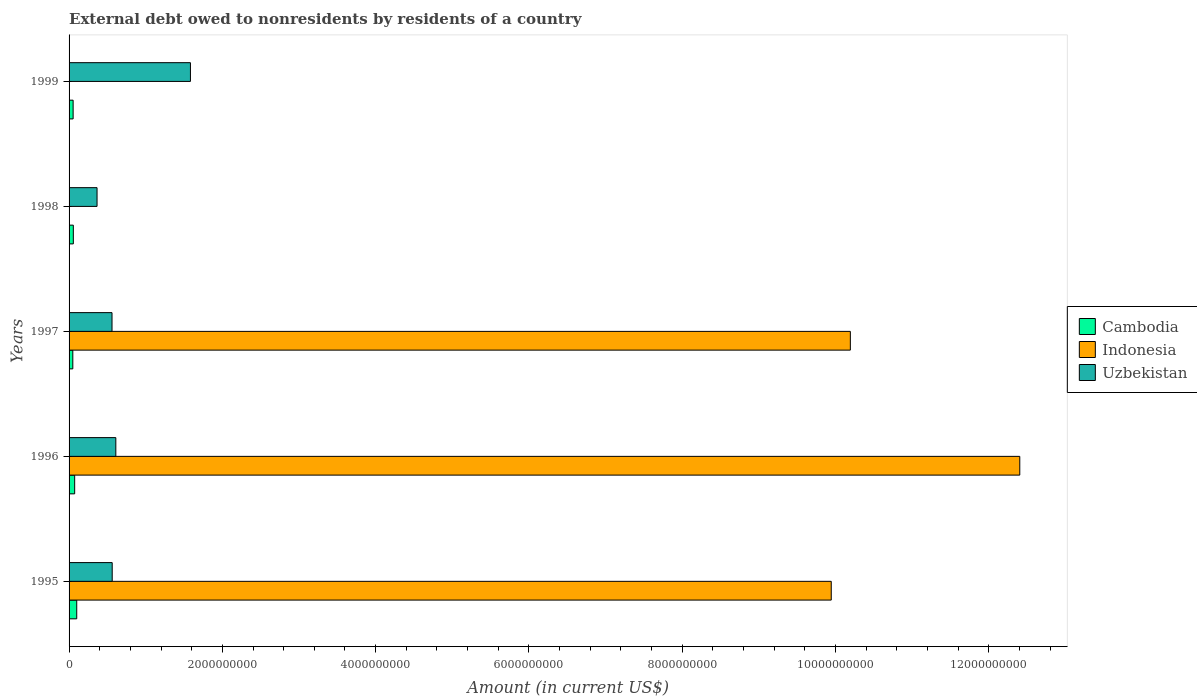How many groups of bars are there?
Your response must be concise. 5. Are the number of bars on each tick of the Y-axis equal?
Offer a terse response. No. What is the label of the 1st group of bars from the top?
Provide a succinct answer. 1999. Across all years, what is the maximum external debt owed by residents in Indonesia?
Your answer should be very brief. 1.24e+1. Across all years, what is the minimum external debt owed by residents in Indonesia?
Your answer should be compact. 0. What is the total external debt owed by residents in Indonesia in the graph?
Ensure brevity in your answer.  3.25e+1. What is the difference between the external debt owed by residents in Uzbekistan in 1996 and that in 1997?
Your answer should be very brief. 4.98e+07. What is the difference between the external debt owed by residents in Indonesia in 1996 and the external debt owed by residents in Uzbekistan in 1995?
Your answer should be very brief. 1.18e+1. What is the average external debt owed by residents in Uzbekistan per year?
Ensure brevity in your answer.  7.36e+08. In the year 1997, what is the difference between the external debt owed by residents in Indonesia and external debt owed by residents in Cambodia?
Provide a succinct answer. 1.01e+1. In how many years, is the external debt owed by residents in Indonesia greater than 11200000000 US$?
Make the answer very short. 1. What is the ratio of the external debt owed by residents in Uzbekistan in 1995 to that in 1996?
Your answer should be compact. 0.92. What is the difference between the highest and the second highest external debt owed by residents in Cambodia?
Your answer should be compact. 2.69e+07. What is the difference between the highest and the lowest external debt owed by residents in Uzbekistan?
Your answer should be compact. 1.22e+09. In how many years, is the external debt owed by residents in Cambodia greater than the average external debt owed by residents in Cambodia taken over all years?
Give a very brief answer. 2. How many bars are there?
Give a very brief answer. 13. Are all the bars in the graph horizontal?
Give a very brief answer. Yes. How are the legend labels stacked?
Make the answer very short. Vertical. What is the title of the graph?
Ensure brevity in your answer.  External debt owed to nonresidents by residents of a country. Does "Ecuador" appear as one of the legend labels in the graph?
Offer a terse response. No. What is the label or title of the X-axis?
Offer a very short reply. Amount (in current US$). What is the label or title of the Y-axis?
Your response must be concise. Years. What is the Amount (in current US$) of Cambodia in 1995?
Make the answer very short. 1.00e+08. What is the Amount (in current US$) in Indonesia in 1995?
Provide a succinct answer. 9.94e+09. What is the Amount (in current US$) in Uzbekistan in 1995?
Ensure brevity in your answer.  5.63e+08. What is the Amount (in current US$) in Cambodia in 1996?
Your answer should be very brief. 7.31e+07. What is the Amount (in current US$) in Indonesia in 1996?
Ensure brevity in your answer.  1.24e+1. What is the Amount (in current US$) of Uzbekistan in 1996?
Provide a succinct answer. 6.10e+08. What is the Amount (in current US$) in Cambodia in 1997?
Offer a very short reply. 4.88e+07. What is the Amount (in current US$) in Indonesia in 1997?
Keep it short and to the point. 1.02e+1. What is the Amount (in current US$) of Uzbekistan in 1997?
Offer a terse response. 5.60e+08. What is the Amount (in current US$) of Cambodia in 1998?
Your answer should be very brief. 5.55e+07. What is the Amount (in current US$) of Uzbekistan in 1998?
Provide a short and direct response. 3.65e+08. What is the Amount (in current US$) in Cambodia in 1999?
Offer a very short reply. 5.28e+07. What is the Amount (in current US$) of Uzbekistan in 1999?
Your answer should be compact. 1.58e+09. Across all years, what is the maximum Amount (in current US$) of Cambodia?
Provide a short and direct response. 1.00e+08. Across all years, what is the maximum Amount (in current US$) in Indonesia?
Offer a very short reply. 1.24e+1. Across all years, what is the maximum Amount (in current US$) of Uzbekistan?
Give a very brief answer. 1.58e+09. Across all years, what is the minimum Amount (in current US$) in Cambodia?
Provide a short and direct response. 4.88e+07. Across all years, what is the minimum Amount (in current US$) of Indonesia?
Make the answer very short. 0. Across all years, what is the minimum Amount (in current US$) of Uzbekistan?
Keep it short and to the point. 3.65e+08. What is the total Amount (in current US$) of Cambodia in the graph?
Your answer should be compact. 3.30e+08. What is the total Amount (in current US$) of Indonesia in the graph?
Your response must be concise. 3.25e+1. What is the total Amount (in current US$) of Uzbekistan in the graph?
Offer a terse response. 3.68e+09. What is the difference between the Amount (in current US$) of Cambodia in 1995 and that in 1996?
Provide a short and direct response. 2.69e+07. What is the difference between the Amount (in current US$) of Indonesia in 1995 and that in 1996?
Ensure brevity in your answer.  -2.46e+09. What is the difference between the Amount (in current US$) in Uzbekistan in 1995 and that in 1996?
Provide a succinct answer. -4.74e+07. What is the difference between the Amount (in current US$) in Cambodia in 1995 and that in 1997?
Your answer should be compact. 5.12e+07. What is the difference between the Amount (in current US$) in Indonesia in 1995 and that in 1997?
Your answer should be compact. -2.49e+08. What is the difference between the Amount (in current US$) in Uzbekistan in 1995 and that in 1997?
Your response must be concise. 2.35e+06. What is the difference between the Amount (in current US$) of Cambodia in 1995 and that in 1998?
Make the answer very short. 4.45e+07. What is the difference between the Amount (in current US$) in Uzbekistan in 1995 and that in 1998?
Keep it short and to the point. 1.98e+08. What is the difference between the Amount (in current US$) of Cambodia in 1995 and that in 1999?
Ensure brevity in your answer.  4.71e+07. What is the difference between the Amount (in current US$) of Uzbekistan in 1995 and that in 1999?
Ensure brevity in your answer.  -1.02e+09. What is the difference between the Amount (in current US$) in Cambodia in 1996 and that in 1997?
Ensure brevity in your answer.  2.43e+07. What is the difference between the Amount (in current US$) of Indonesia in 1996 and that in 1997?
Offer a terse response. 2.21e+09. What is the difference between the Amount (in current US$) in Uzbekistan in 1996 and that in 1997?
Make the answer very short. 4.98e+07. What is the difference between the Amount (in current US$) in Cambodia in 1996 and that in 1998?
Ensure brevity in your answer.  1.76e+07. What is the difference between the Amount (in current US$) of Uzbekistan in 1996 and that in 1998?
Your answer should be very brief. 2.45e+08. What is the difference between the Amount (in current US$) in Cambodia in 1996 and that in 1999?
Your answer should be compact. 2.03e+07. What is the difference between the Amount (in current US$) in Uzbekistan in 1996 and that in 1999?
Offer a terse response. -9.73e+08. What is the difference between the Amount (in current US$) in Cambodia in 1997 and that in 1998?
Make the answer very short. -6.68e+06. What is the difference between the Amount (in current US$) of Uzbekistan in 1997 and that in 1998?
Provide a short and direct response. 1.95e+08. What is the difference between the Amount (in current US$) of Cambodia in 1997 and that in 1999?
Ensure brevity in your answer.  -4.00e+06. What is the difference between the Amount (in current US$) of Uzbekistan in 1997 and that in 1999?
Keep it short and to the point. -1.02e+09. What is the difference between the Amount (in current US$) in Cambodia in 1998 and that in 1999?
Provide a succinct answer. 2.68e+06. What is the difference between the Amount (in current US$) of Uzbekistan in 1998 and that in 1999?
Ensure brevity in your answer.  -1.22e+09. What is the difference between the Amount (in current US$) of Cambodia in 1995 and the Amount (in current US$) of Indonesia in 1996?
Provide a short and direct response. -1.23e+1. What is the difference between the Amount (in current US$) of Cambodia in 1995 and the Amount (in current US$) of Uzbekistan in 1996?
Your response must be concise. -5.10e+08. What is the difference between the Amount (in current US$) in Indonesia in 1995 and the Amount (in current US$) in Uzbekistan in 1996?
Ensure brevity in your answer.  9.33e+09. What is the difference between the Amount (in current US$) in Cambodia in 1995 and the Amount (in current US$) in Indonesia in 1997?
Your answer should be very brief. -1.01e+1. What is the difference between the Amount (in current US$) in Cambodia in 1995 and the Amount (in current US$) in Uzbekistan in 1997?
Offer a terse response. -4.60e+08. What is the difference between the Amount (in current US$) in Indonesia in 1995 and the Amount (in current US$) in Uzbekistan in 1997?
Offer a terse response. 9.38e+09. What is the difference between the Amount (in current US$) in Cambodia in 1995 and the Amount (in current US$) in Uzbekistan in 1998?
Provide a succinct answer. -2.65e+08. What is the difference between the Amount (in current US$) of Indonesia in 1995 and the Amount (in current US$) of Uzbekistan in 1998?
Make the answer very short. 9.58e+09. What is the difference between the Amount (in current US$) in Cambodia in 1995 and the Amount (in current US$) in Uzbekistan in 1999?
Give a very brief answer. -1.48e+09. What is the difference between the Amount (in current US$) in Indonesia in 1995 and the Amount (in current US$) in Uzbekistan in 1999?
Provide a succinct answer. 8.36e+09. What is the difference between the Amount (in current US$) of Cambodia in 1996 and the Amount (in current US$) of Indonesia in 1997?
Make the answer very short. -1.01e+1. What is the difference between the Amount (in current US$) of Cambodia in 1996 and the Amount (in current US$) of Uzbekistan in 1997?
Ensure brevity in your answer.  -4.87e+08. What is the difference between the Amount (in current US$) in Indonesia in 1996 and the Amount (in current US$) in Uzbekistan in 1997?
Give a very brief answer. 1.18e+1. What is the difference between the Amount (in current US$) in Cambodia in 1996 and the Amount (in current US$) in Uzbekistan in 1998?
Give a very brief answer. -2.92e+08. What is the difference between the Amount (in current US$) of Indonesia in 1996 and the Amount (in current US$) of Uzbekistan in 1998?
Give a very brief answer. 1.20e+1. What is the difference between the Amount (in current US$) of Cambodia in 1996 and the Amount (in current US$) of Uzbekistan in 1999?
Ensure brevity in your answer.  -1.51e+09. What is the difference between the Amount (in current US$) of Indonesia in 1996 and the Amount (in current US$) of Uzbekistan in 1999?
Give a very brief answer. 1.08e+1. What is the difference between the Amount (in current US$) of Cambodia in 1997 and the Amount (in current US$) of Uzbekistan in 1998?
Keep it short and to the point. -3.16e+08. What is the difference between the Amount (in current US$) in Indonesia in 1997 and the Amount (in current US$) in Uzbekistan in 1998?
Your answer should be very brief. 9.83e+09. What is the difference between the Amount (in current US$) of Cambodia in 1997 and the Amount (in current US$) of Uzbekistan in 1999?
Provide a short and direct response. -1.53e+09. What is the difference between the Amount (in current US$) in Indonesia in 1997 and the Amount (in current US$) in Uzbekistan in 1999?
Offer a very short reply. 8.61e+09. What is the difference between the Amount (in current US$) of Cambodia in 1998 and the Amount (in current US$) of Uzbekistan in 1999?
Offer a very short reply. -1.53e+09. What is the average Amount (in current US$) in Cambodia per year?
Offer a very short reply. 6.60e+07. What is the average Amount (in current US$) of Indonesia per year?
Your response must be concise. 6.51e+09. What is the average Amount (in current US$) in Uzbekistan per year?
Provide a succinct answer. 7.36e+08. In the year 1995, what is the difference between the Amount (in current US$) of Cambodia and Amount (in current US$) of Indonesia?
Offer a terse response. -9.84e+09. In the year 1995, what is the difference between the Amount (in current US$) in Cambodia and Amount (in current US$) in Uzbekistan?
Your answer should be very brief. -4.63e+08. In the year 1995, what is the difference between the Amount (in current US$) in Indonesia and Amount (in current US$) in Uzbekistan?
Keep it short and to the point. 9.38e+09. In the year 1996, what is the difference between the Amount (in current US$) of Cambodia and Amount (in current US$) of Indonesia?
Offer a terse response. -1.23e+1. In the year 1996, what is the difference between the Amount (in current US$) of Cambodia and Amount (in current US$) of Uzbekistan?
Offer a very short reply. -5.37e+08. In the year 1996, what is the difference between the Amount (in current US$) in Indonesia and Amount (in current US$) in Uzbekistan?
Make the answer very short. 1.18e+1. In the year 1997, what is the difference between the Amount (in current US$) of Cambodia and Amount (in current US$) of Indonesia?
Offer a terse response. -1.01e+1. In the year 1997, what is the difference between the Amount (in current US$) in Cambodia and Amount (in current US$) in Uzbekistan?
Your response must be concise. -5.12e+08. In the year 1997, what is the difference between the Amount (in current US$) of Indonesia and Amount (in current US$) of Uzbekistan?
Give a very brief answer. 9.63e+09. In the year 1998, what is the difference between the Amount (in current US$) of Cambodia and Amount (in current US$) of Uzbekistan?
Give a very brief answer. -3.09e+08. In the year 1999, what is the difference between the Amount (in current US$) in Cambodia and Amount (in current US$) in Uzbekistan?
Provide a succinct answer. -1.53e+09. What is the ratio of the Amount (in current US$) in Cambodia in 1995 to that in 1996?
Give a very brief answer. 1.37. What is the ratio of the Amount (in current US$) in Indonesia in 1995 to that in 1996?
Offer a very short reply. 0.8. What is the ratio of the Amount (in current US$) in Uzbekistan in 1995 to that in 1996?
Make the answer very short. 0.92. What is the ratio of the Amount (in current US$) of Cambodia in 1995 to that in 1997?
Offer a very short reply. 2.05. What is the ratio of the Amount (in current US$) of Indonesia in 1995 to that in 1997?
Provide a short and direct response. 0.98. What is the ratio of the Amount (in current US$) of Cambodia in 1995 to that in 1998?
Provide a succinct answer. 1.8. What is the ratio of the Amount (in current US$) of Uzbekistan in 1995 to that in 1998?
Provide a short and direct response. 1.54. What is the ratio of the Amount (in current US$) in Cambodia in 1995 to that in 1999?
Your answer should be compact. 1.89. What is the ratio of the Amount (in current US$) of Uzbekistan in 1995 to that in 1999?
Offer a terse response. 0.36. What is the ratio of the Amount (in current US$) of Cambodia in 1996 to that in 1997?
Provide a short and direct response. 1.5. What is the ratio of the Amount (in current US$) of Indonesia in 1996 to that in 1997?
Offer a very short reply. 1.22. What is the ratio of the Amount (in current US$) of Uzbekistan in 1996 to that in 1997?
Your response must be concise. 1.09. What is the ratio of the Amount (in current US$) in Cambodia in 1996 to that in 1998?
Provide a succinct answer. 1.32. What is the ratio of the Amount (in current US$) of Uzbekistan in 1996 to that in 1998?
Your answer should be compact. 1.67. What is the ratio of the Amount (in current US$) in Cambodia in 1996 to that in 1999?
Your answer should be very brief. 1.38. What is the ratio of the Amount (in current US$) of Uzbekistan in 1996 to that in 1999?
Your answer should be very brief. 0.39. What is the ratio of the Amount (in current US$) in Cambodia in 1997 to that in 1998?
Provide a short and direct response. 0.88. What is the ratio of the Amount (in current US$) in Uzbekistan in 1997 to that in 1998?
Your response must be concise. 1.54. What is the ratio of the Amount (in current US$) in Cambodia in 1997 to that in 1999?
Your answer should be very brief. 0.92. What is the ratio of the Amount (in current US$) in Uzbekistan in 1997 to that in 1999?
Provide a succinct answer. 0.35. What is the ratio of the Amount (in current US$) of Cambodia in 1998 to that in 1999?
Offer a very short reply. 1.05. What is the ratio of the Amount (in current US$) of Uzbekistan in 1998 to that in 1999?
Offer a terse response. 0.23. What is the difference between the highest and the second highest Amount (in current US$) in Cambodia?
Provide a short and direct response. 2.69e+07. What is the difference between the highest and the second highest Amount (in current US$) of Indonesia?
Your response must be concise. 2.21e+09. What is the difference between the highest and the second highest Amount (in current US$) in Uzbekistan?
Your response must be concise. 9.73e+08. What is the difference between the highest and the lowest Amount (in current US$) of Cambodia?
Your answer should be compact. 5.12e+07. What is the difference between the highest and the lowest Amount (in current US$) in Indonesia?
Provide a short and direct response. 1.24e+1. What is the difference between the highest and the lowest Amount (in current US$) in Uzbekistan?
Provide a succinct answer. 1.22e+09. 